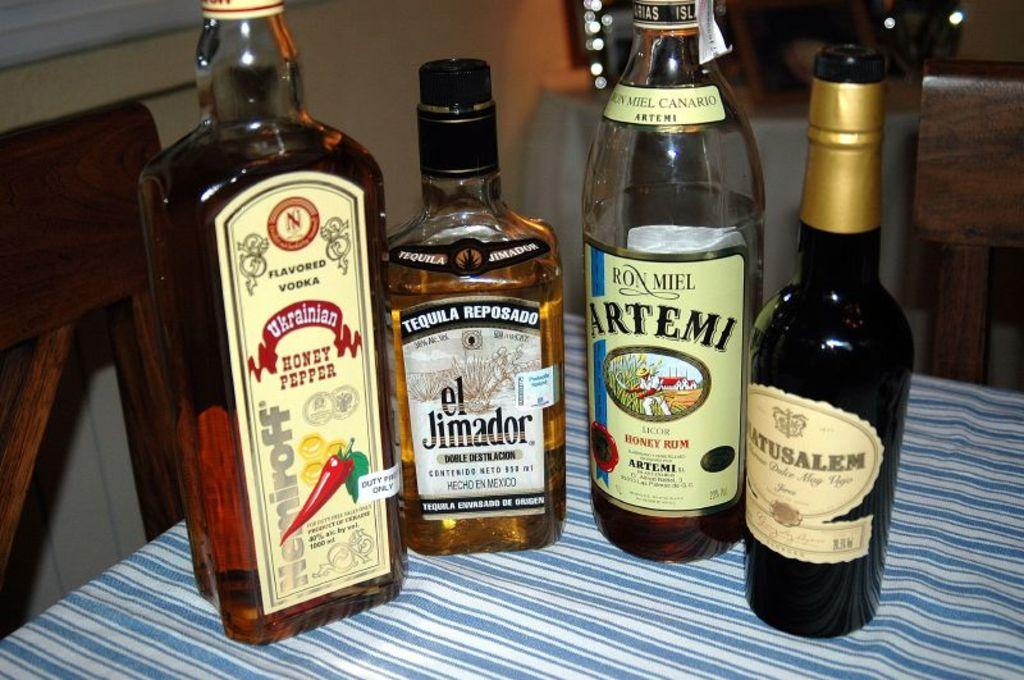<image>
Describe the image concisely. four bottles of alcohol, including a bottle of el Jimador are sitting on a table 